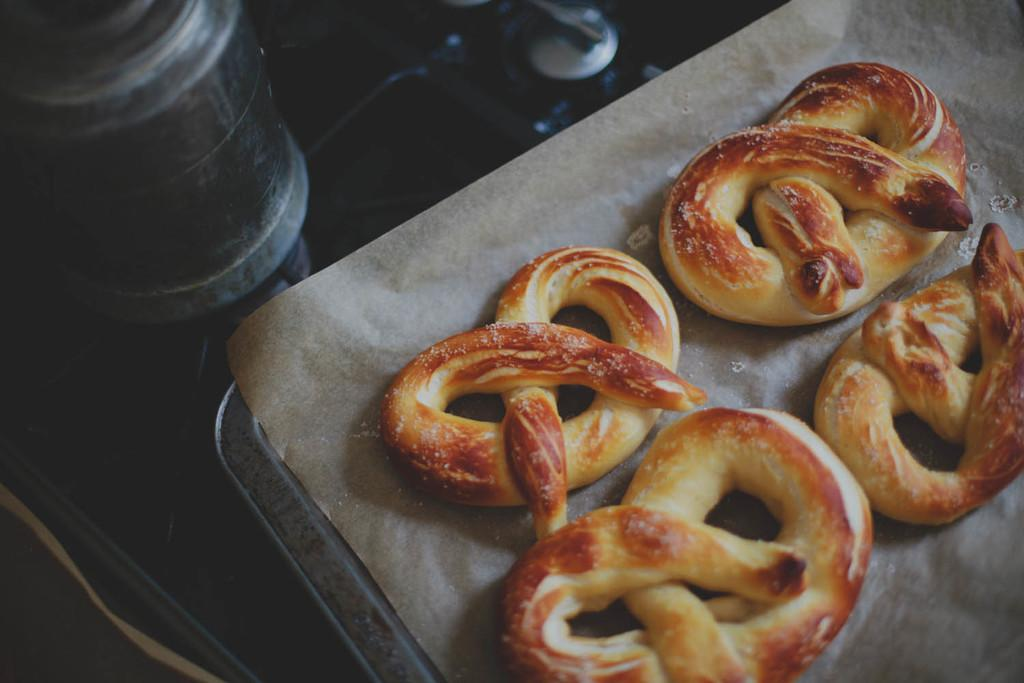What type of food is present in the image? There are pretzels in the image. What type of pen is being used to stitch the plane in the image? There is no pen, stitching, or plane present in the image; it only features pretzels. 